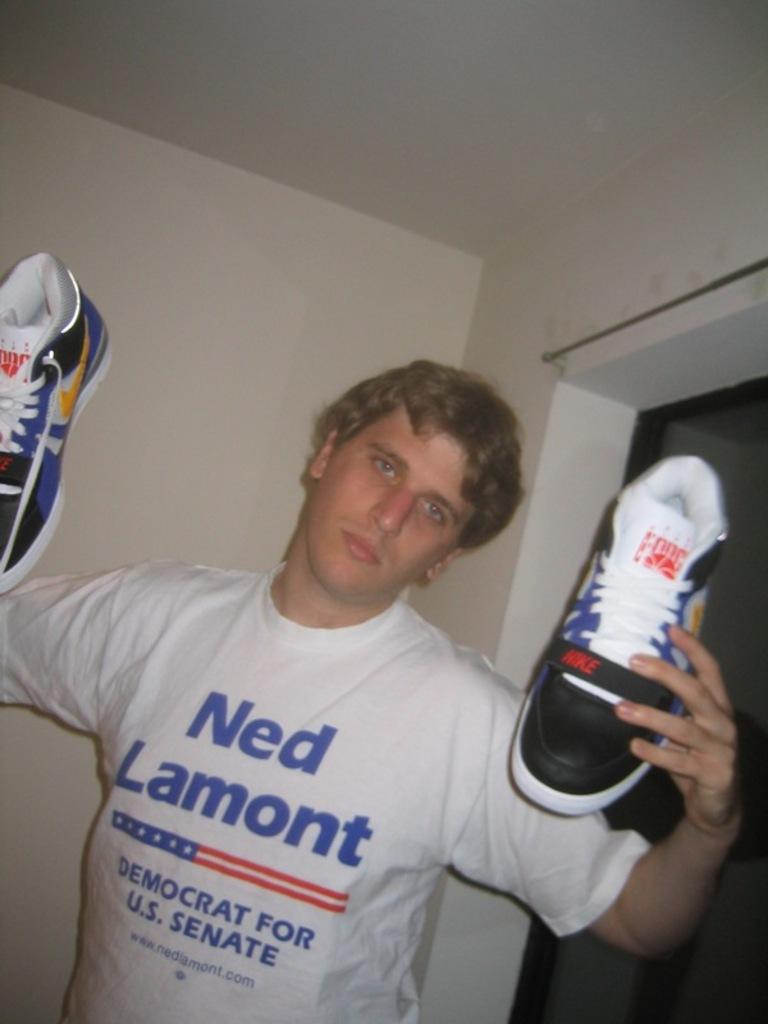Provide a one-sentence caption for the provided image. A boy in a Ned Lamont shirt holding a pair of shoes. 